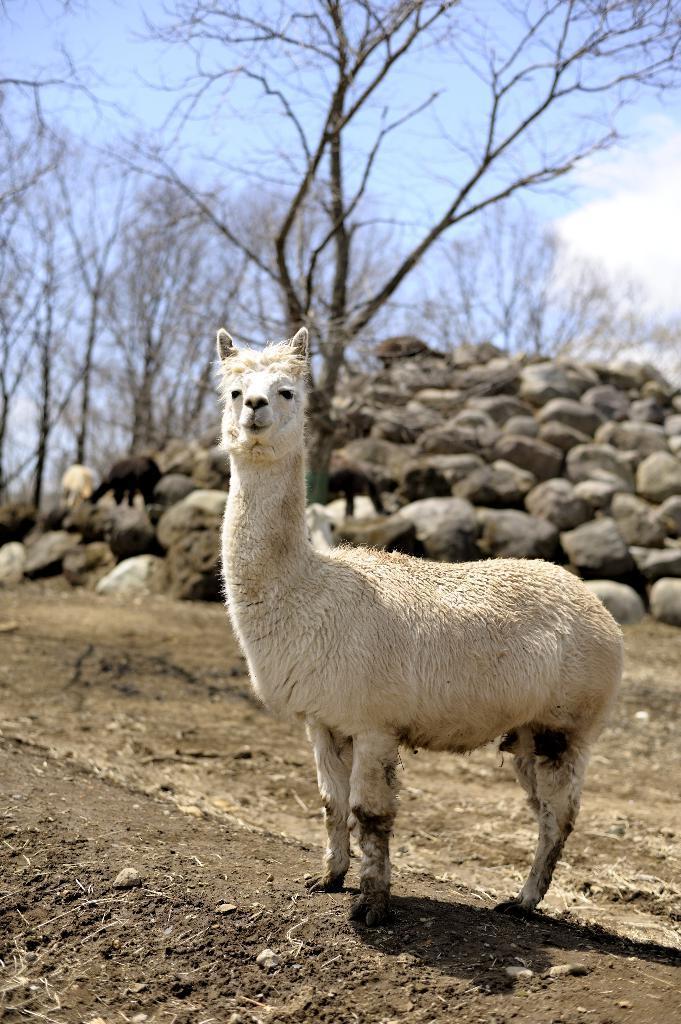Describe this image in one or two sentences. In this image I can see an animal in white color. Back I can see few rocks, dry trees and sky is in blue and white color. 